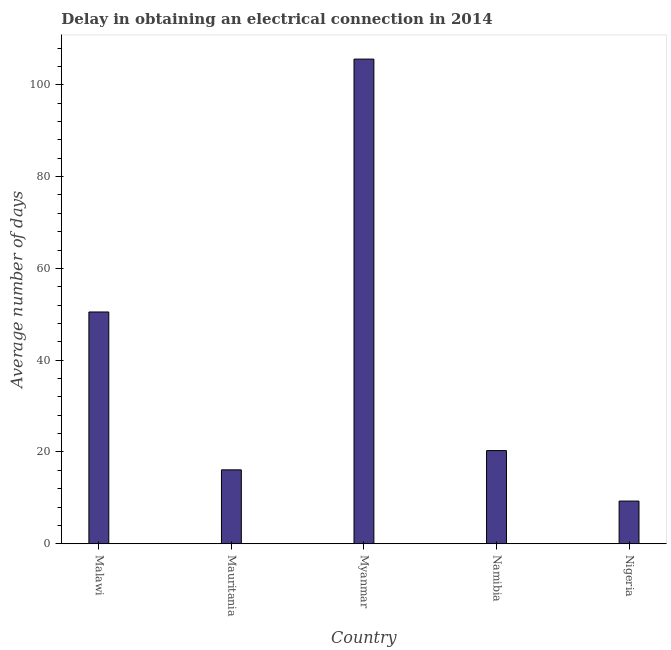Does the graph contain grids?
Keep it short and to the point. No. What is the title of the graph?
Provide a short and direct response. Delay in obtaining an electrical connection in 2014. What is the label or title of the Y-axis?
Your response must be concise. Average number of days. Across all countries, what is the maximum dalay in electrical connection?
Offer a terse response. 105.6. In which country was the dalay in electrical connection maximum?
Provide a short and direct response. Myanmar. In which country was the dalay in electrical connection minimum?
Your response must be concise. Nigeria. What is the sum of the dalay in electrical connection?
Give a very brief answer. 201.8. What is the difference between the dalay in electrical connection in Mauritania and Myanmar?
Your answer should be compact. -89.5. What is the average dalay in electrical connection per country?
Ensure brevity in your answer.  40.36. What is the median dalay in electrical connection?
Your answer should be compact. 20.3. What is the ratio of the dalay in electrical connection in Malawi to that in Myanmar?
Your answer should be very brief. 0.48. What is the difference between the highest and the second highest dalay in electrical connection?
Offer a very short reply. 55.1. What is the difference between the highest and the lowest dalay in electrical connection?
Offer a terse response. 96.3. How many bars are there?
Give a very brief answer. 5. How many countries are there in the graph?
Ensure brevity in your answer.  5. What is the difference between two consecutive major ticks on the Y-axis?
Your answer should be compact. 20. Are the values on the major ticks of Y-axis written in scientific E-notation?
Ensure brevity in your answer.  No. What is the Average number of days in Malawi?
Provide a succinct answer. 50.5. What is the Average number of days of Mauritania?
Provide a succinct answer. 16.1. What is the Average number of days of Myanmar?
Give a very brief answer. 105.6. What is the Average number of days of Namibia?
Your answer should be very brief. 20.3. What is the difference between the Average number of days in Malawi and Mauritania?
Keep it short and to the point. 34.4. What is the difference between the Average number of days in Malawi and Myanmar?
Your answer should be compact. -55.1. What is the difference between the Average number of days in Malawi and Namibia?
Offer a terse response. 30.2. What is the difference between the Average number of days in Malawi and Nigeria?
Ensure brevity in your answer.  41.2. What is the difference between the Average number of days in Mauritania and Myanmar?
Provide a short and direct response. -89.5. What is the difference between the Average number of days in Mauritania and Namibia?
Provide a succinct answer. -4.2. What is the difference between the Average number of days in Myanmar and Namibia?
Your answer should be compact. 85.3. What is the difference between the Average number of days in Myanmar and Nigeria?
Keep it short and to the point. 96.3. What is the difference between the Average number of days in Namibia and Nigeria?
Your answer should be compact. 11. What is the ratio of the Average number of days in Malawi to that in Mauritania?
Your answer should be very brief. 3.14. What is the ratio of the Average number of days in Malawi to that in Myanmar?
Your answer should be very brief. 0.48. What is the ratio of the Average number of days in Malawi to that in Namibia?
Offer a terse response. 2.49. What is the ratio of the Average number of days in Malawi to that in Nigeria?
Make the answer very short. 5.43. What is the ratio of the Average number of days in Mauritania to that in Myanmar?
Provide a short and direct response. 0.15. What is the ratio of the Average number of days in Mauritania to that in Namibia?
Provide a succinct answer. 0.79. What is the ratio of the Average number of days in Mauritania to that in Nigeria?
Ensure brevity in your answer.  1.73. What is the ratio of the Average number of days in Myanmar to that in Namibia?
Ensure brevity in your answer.  5.2. What is the ratio of the Average number of days in Myanmar to that in Nigeria?
Give a very brief answer. 11.36. What is the ratio of the Average number of days in Namibia to that in Nigeria?
Provide a succinct answer. 2.18. 